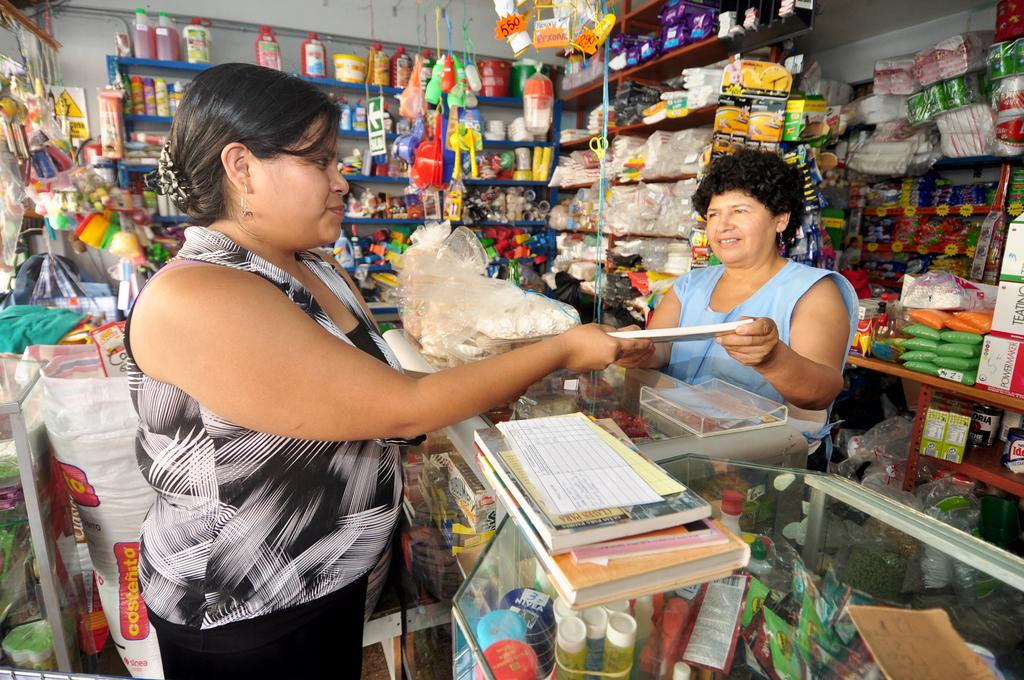Provide a one-sentence caption for the provided image. A bag with costenito printed on it is behind a women in a store. 